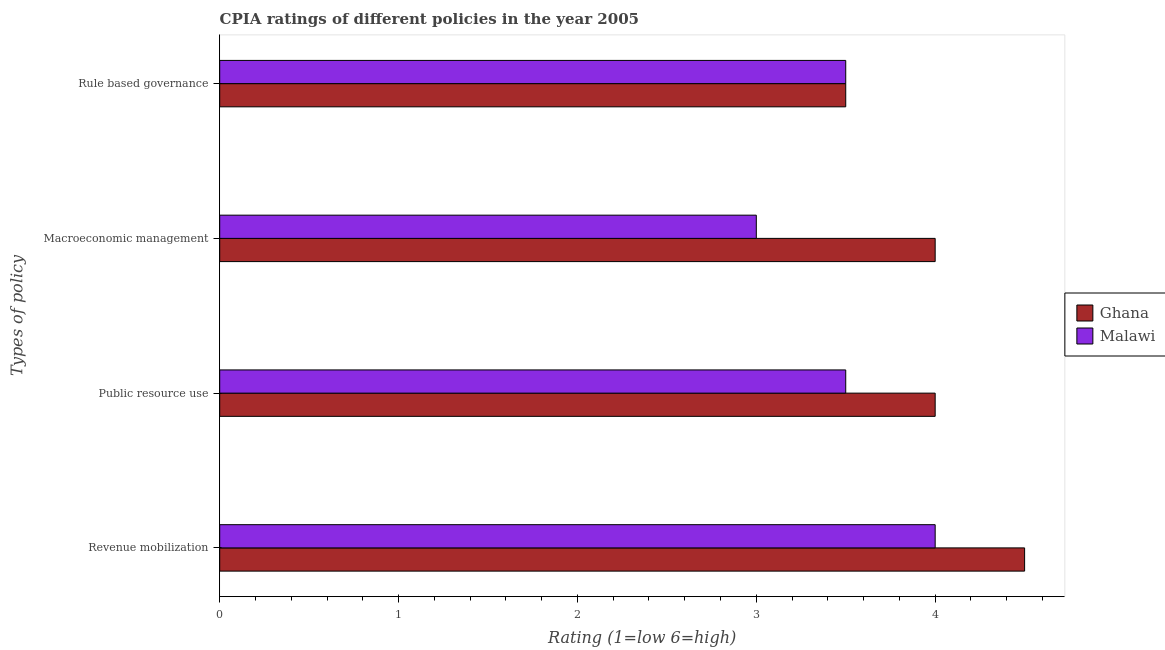How many different coloured bars are there?
Your answer should be very brief. 2. Are the number of bars per tick equal to the number of legend labels?
Offer a very short reply. Yes. Are the number of bars on each tick of the Y-axis equal?
Your answer should be compact. Yes. What is the label of the 1st group of bars from the top?
Keep it short and to the point. Rule based governance. What is the cpia rating of rule based governance in Ghana?
Ensure brevity in your answer.  3.5. Across all countries, what is the maximum cpia rating of macroeconomic management?
Offer a terse response. 4. In which country was the cpia rating of public resource use minimum?
Offer a terse response. Malawi. What is the total cpia rating of macroeconomic management in the graph?
Your answer should be compact. 7. What is the difference between the cpia rating of public resource use in Ghana and that in Malawi?
Provide a succinct answer. 0.5. What is the difference between the cpia rating of macroeconomic management in Malawi and the cpia rating of rule based governance in Ghana?
Provide a short and direct response. -0.5. What is the average cpia rating of public resource use per country?
Provide a short and direct response. 3.75. What is the difference between the cpia rating of rule based governance and cpia rating of public resource use in Ghana?
Your answer should be compact. -0.5. What is the difference between the highest and the second highest cpia rating of revenue mobilization?
Keep it short and to the point. 0.5. What is the difference between the highest and the lowest cpia rating of revenue mobilization?
Your answer should be compact. 0.5. Is the sum of the cpia rating of rule based governance in Ghana and Malawi greater than the maximum cpia rating of public resource use across all countries?
Offer a very short reply. Yes. What does the 1st bar from the top in Public resource use represents?
Provide a short and direct response. Malawi. What does the 2nd bar from the bottom in Macroeconomic management represents?
Give a very brief answer. Malawi. Is it the case that in every country, the sum of the cpia rating of revenue mobilization and cpia rating of public resource use is greater than the cpia rating of macroeconomic management?
Your answer should be compact. Yes. What is the difference between two consecutive major ticks on the X-axis?
Give a very brief answer. 1. Does the graph contain grids?
Give a very brief answer. No. How are the legend labels stacked?
Your answer should be compact. Vertical. What is the title of the graph?
Offer a very short reply. CPIA ratings of different policies in the year 2005. What is the label or title of the X-axis?
Provide a succinct answer. Rating (1=low 6=high). What is the label or title of the Y-axis?
Your answer should be compact. Types of policy. What is the Rating (1=low 6=high) in Malawi in Revenue mobilization?
Make the answer very short. 4. What is the Rating (1=low 6=high) of Ghana in Public resource use?
Your answer should be compact. 4. What is the Rating (1=low 6=high) in Malawi in Macroeconomic management?
Provide a short and direct response. 3. What is the Rating (1=low 6=high) of Malawi in Rule based governance?
Make the answer very short. 3.5. Across all Types of policy, what is the maximum Rating (1=low 6=high) in Ghana?
Provide a succinct answer. 4.5. What is the difference between the Rating (1=low 6=high) of Malawi in Revenue mobilization and that in Public resource use?
Keep it short and to the point. 0.5. What is the difference between the Rating (1=low 6=high) in Ghana in Revenue mobilization and that in Macroeconomic management?
Provide a short and direct response. 0.5. What is the difference between the Rating (1=low 6=high) of Ghana in Revenue mobilization and that in Rule based governance?
Provide a succinct answer. 1. What is the difference between the Rating (1=low 6=high) of Malawi in Public resource use and that in Macroeconomic management?
Offer a very short reply. 0.5. What is the difference between the Rating (1=low 6=high) of Ghana in Public resource use and that in Rule based governance?
Your answer should be compact. 0.5. What is the difference between the Rating (1=low 6=high) in Malawi in Public resource use and that in Rule based governance?
Make the answer very short. 0. What is the difference between the Rating (1=low 6=high) in Ghana in Revenue mobilization and the Rating (1=low 6=high) in Malawi in Public resource use?
Make the answer very short. 1. What is the difference between the Rating (1=low 6=high) of Ghana in Macroeconomic management and the Rating (1=low 6=high) of Malawi in Rule based governance?
Provide a succinct answer. 0.5. What is the average Rating (1=low 6=high) of Malawi per Types of policy?
Your response must be concise. 3.5. What is the difference between the Rating (1=low 6=high) of Ghana and Rating (1=low 6=high) of Malawi in Revenue mobilization?
Your answer should be very brief. 0.5. What is the difference between the Rating (1=low 6=high) in Ghana and Rating (1=low 6=high) in Malawi in Public resource use?
Keep it short and to the point. 0.5. What is the difference between the Rating (1=low 6=high) of Ghana and Rating (1=low 6=high) of Malawi in Rule based governance?
Provide a short and direct response. 0. What is the ratio of the Rating (1=low 6=high) of Malawi in Revenue mobilization to that in Public resource use?
Keep it short and to the point. 1.14. What is the ratio of the Rating (1=low 6=high) of Ghana in Revenue mobilization to that in Macroeconomic management?
Offer a terse response. 1.12. What is the ratio of the Rating (1=low 6=high) in Malawi in Revenue mobilization to that in Macroeconomic management?
Provide a succinct answer. 1.33. What is the ratio of the Rating (1=low 6=high) in Ghana in Revenue mobilization to that in Rule based governance?
Give a very brief answer. 1.29. What is the ratio of the Rating (1=low 6=high) of Malawi in Revenue mobilization to that in Rule based governance?
Give a very brief answer. 1.14. What is the ratio of the Rating (1=low 6=high) in Malawi in Public resource use to that in Macroeconomic management?
Offer a terse response. 1.17. What is the ratio of the Rating (1=low 6=high) of Ghana in Public resource use to that in Rule based governance?
Your response must be concise. 1.14. What is the ratio of the Rating (1=low 6=high) in Malawi in Public resource use to that in Rule based governance?
Provide a short and direct response. 1. What is the ratio of the Rating (1=low 6=high) of Malawi in Macroeconomic management to that in Rule based governance?
Ensure brevity in your answer.  0.86. What is the difference between the highest and the second highest Rating (1=low 6=high) of Ghana?
Your answer should be compact. 0.5. What is the difference between the highest and the lowest Rating (1=low 6=high) of Malawi?
Your answer should be compact. 1. 